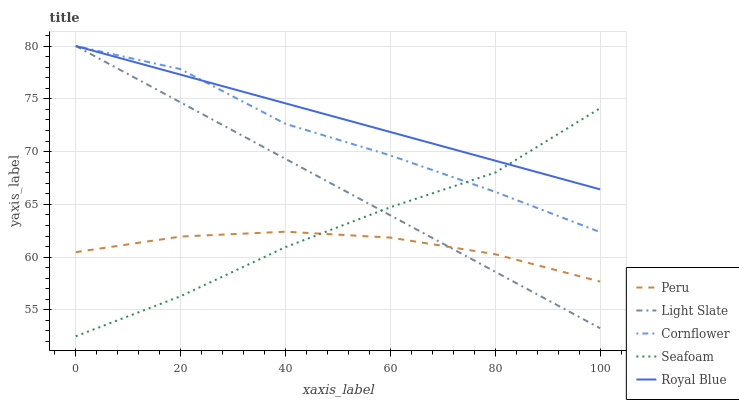Does Cornflower have the minimum area under the curve?
Answer yes or no. No. Does Cornflower have the maximum area under the curve?
Answer yes or no. No. Is Seafoam the smoothest?
Answer yes or no. No. Is Seafoam the roughest?
Answer yes or no. No. Does Cornflower have the lowest value?
Answer yes or no. No. Does Seafoam have the highest value?
Answer yes or no. No. Is Peru less than Cornflower?
Answer yes or no. Yes. Is Cornflower greater than Peru?
Answer yes or no. Yes. Does Peru intersect Cornflower?
Answer yes or no. No. 